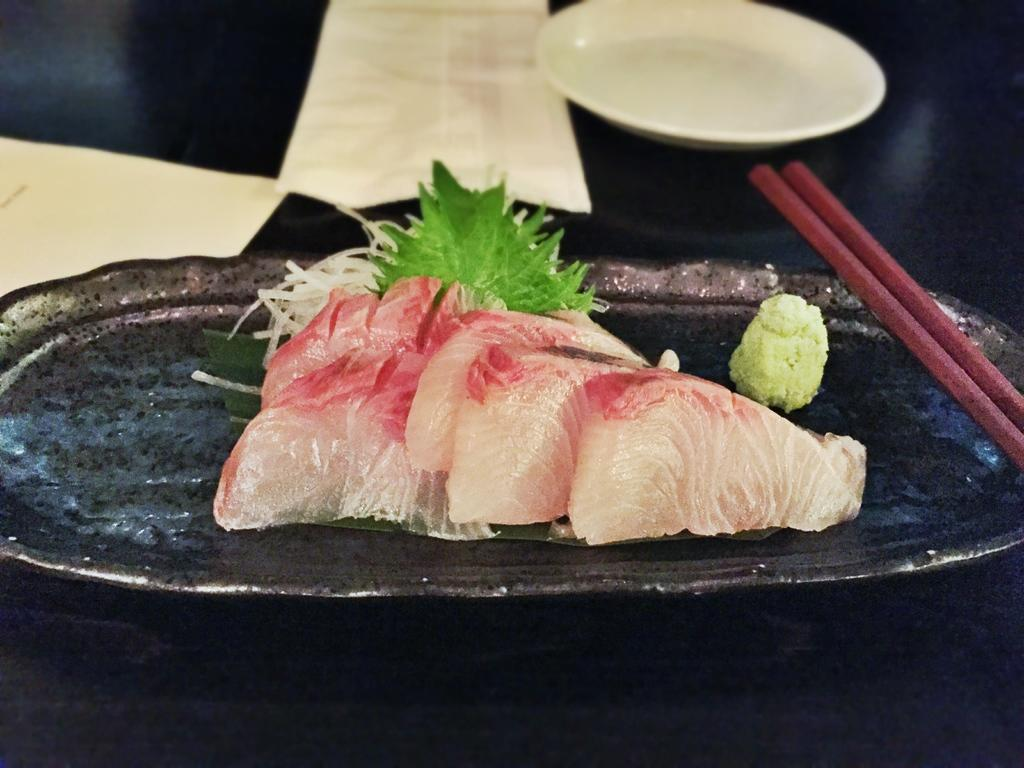What is on the plate that is visible in the image? There is food in a plate in the image. What other dish is present in the image besides the plate? There is a bowl in the image. What utensil is present in the image? There are chopsticks in the image. What type of wool can be seen being pulled in the image? There is no wool or any pulling action present in the image. 